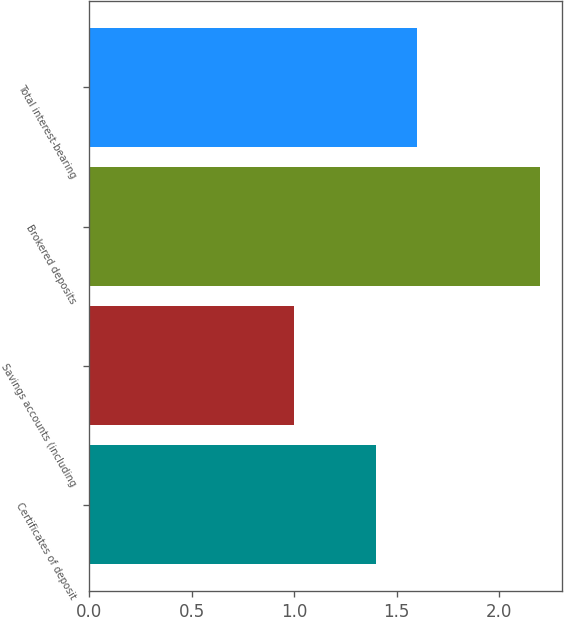<chart> <loc_0><loc_0><loc_500><loc_500><bar_chart><fcel>Certificates of deposit<fcel>Savings accounts (including<fcel>Brokered deposits<fcel>Total interest-bearing<nl><fcel>1.4<fcel>1<fcel>2.2<fcel>1.6<nl></chart> 